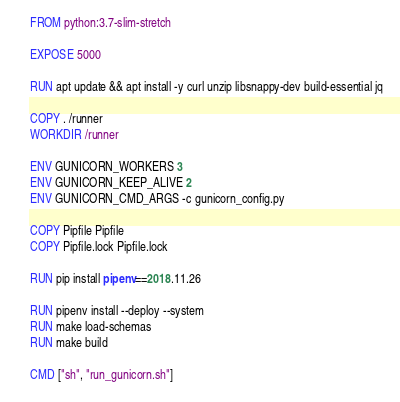<code> <loc_0><loc_0><loc_500><loc_500><_Dockerfile_>FROM python:3.7-slim-stretch

EXPOSE 5000

RUN apt update && apt install -y curl unzip libsnappy-dev build-essential jq

COPY . /runner
WORKDIR /runner

ENV GUNICORN_WORKERS 3
ENV GUNICORN_KEEP_ALIVE 2
ENV GUNICORN_CMD_ARGS -c gunicorn_config.py

COPY Pipfile Pipfile
COPY Pipfile.lock Pipfile.lock

RUN pip install pipenv==2018.11.26

RUN pipenv install --deploy --system
RUN make load-schemas
RUN make build

CMD ["sh", "run_gunicorn.sh"]
</code> 